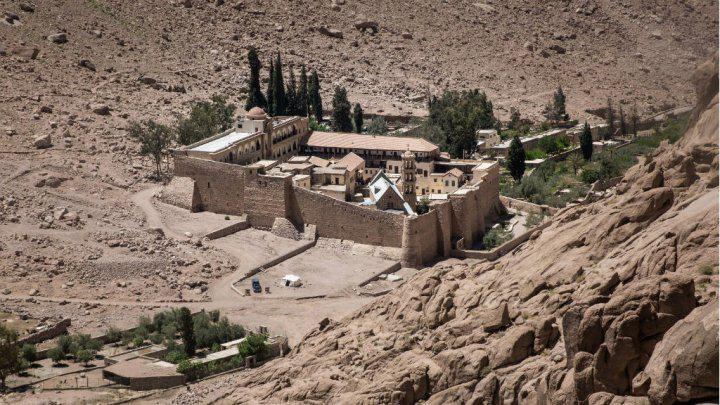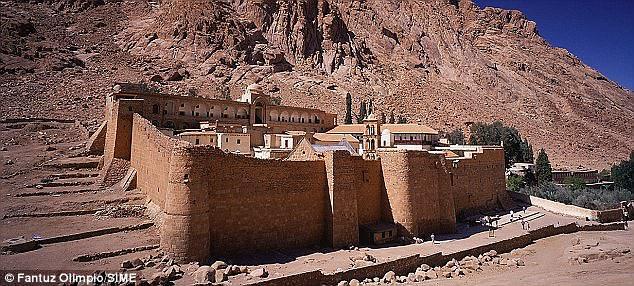The first image is the image on the left, the second image is the image on the right. Analyze the images presented: Is the assertion "All of the boundaries are shown for one walled city in each image." valid? Answer yes or no. Yes. 